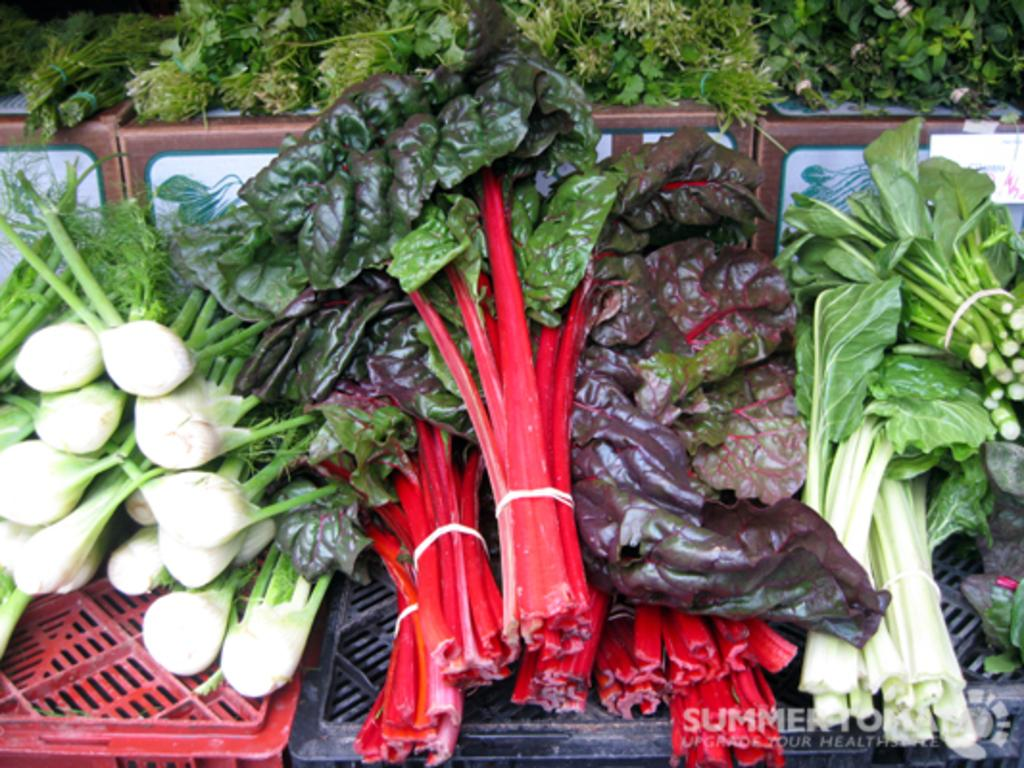What type of vegetables are visible in the image? There are green leafy vegetables in the image. What is the object on which the vegetables are placed? The fact provided does not specify the object on which the vegetables are placed. What type of rabbit can be seen eating the vegetables in the image? There is no rabbit present in the image, and the vegetables are not being eaten. 